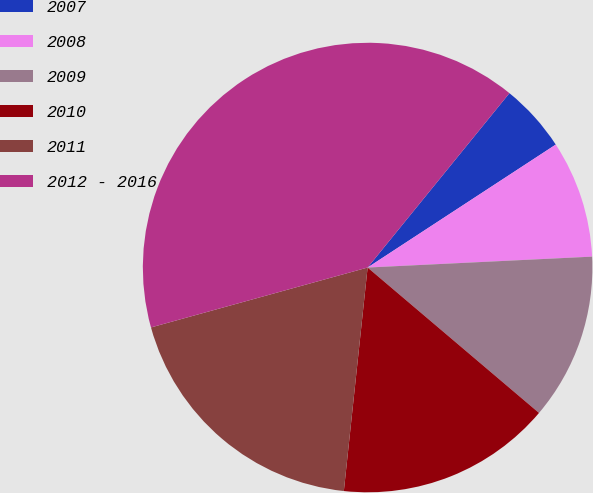Convert chart to OTSL. <chart><loc_0><loc_0><loc_500><loc_500><pie_chart><fcel>2007<fcel>2008<fcel>2009<fcel>2010<fcel>2011<fcel>2012 - 2016<nl><fcel>4.92%<fcel>8.44%<fcel>11.97%<fcel>15.49%<fcel>19.02%<fcel>40.16%<nl></chart> 